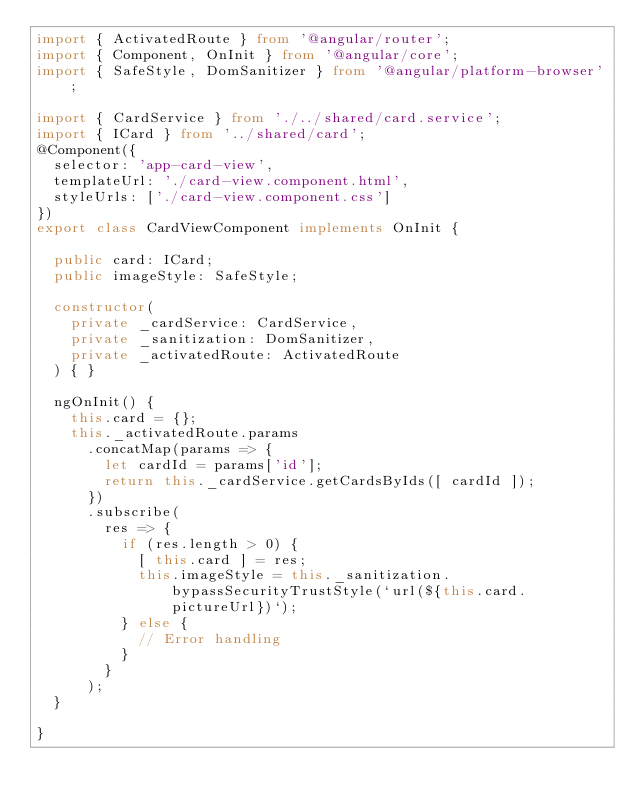Convert code to text. <code><loc_0><loc_0><loc_500><loc_500><_TypeScript_>import { ActivatedRoute } from '@angular/router';
import { Component, OnInit } from '@angular/core';
import { SafeStyle, DomSanitizer } from '@angular/platform-browser';

import { CardService } from './../shared/card.service';
import { ICard } from '../shared/card';
@Component({
  selector: 'app-card-view',
  templateUrl: './card-view.component.html',
  styleUrls: ['./card-view.component.css']
})
export class CardViewComponent implements OnInit {

  public card: ICard;
  public imageStyle: SafeStyle;

  constructor(
    private _cardService: CardService,
    private _sanitization: DomSanitizer,
    private _activatedRoute: ActivatedRoute
  ) { }

  ngOnInit() {
    this.card = {};
    this._activatedRoute.params
      .concatMap(params => {
        let cardId = params['id'];
        return this._cardService.getCardsByIds([ cardId ]);
      })
      .subscribe(
        res => {
          if (res.length > 0) {
            [ this.card ] = res;
            this.imageStyle = this._sanitization.bypassSecurityTrustStyle(`url(${this.card.pictureUrl})`);
          } else {
            // Error handling
          }
        }
      );
  }

}
</code> 